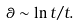Convert formula to latex. <formula><loc_0><loc_0><loc_500><loc_500>\theta \sim \ln { t } / t .</formula> 